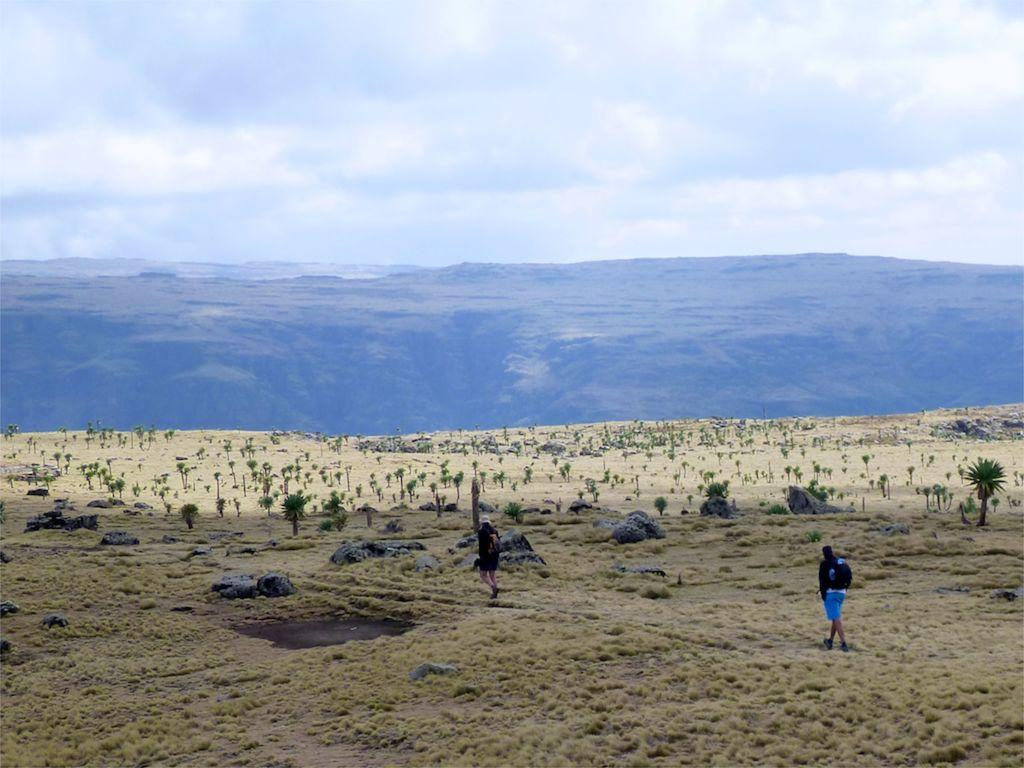What are the people in the image doing? The people in the image are walking. What are the people carrying on their backs? The people are wearing backpacks. What type of natural environment can be seen in the image? There are trees, rocks, and grass visible in the image. How would you describe the weather in the image? The sky is cloudy in the image. What type of lip can be seen on the rocks in the image? There are no lips present in the image, as it features people walking with backpacks in a natural environment with trees, rocks, and grass. 